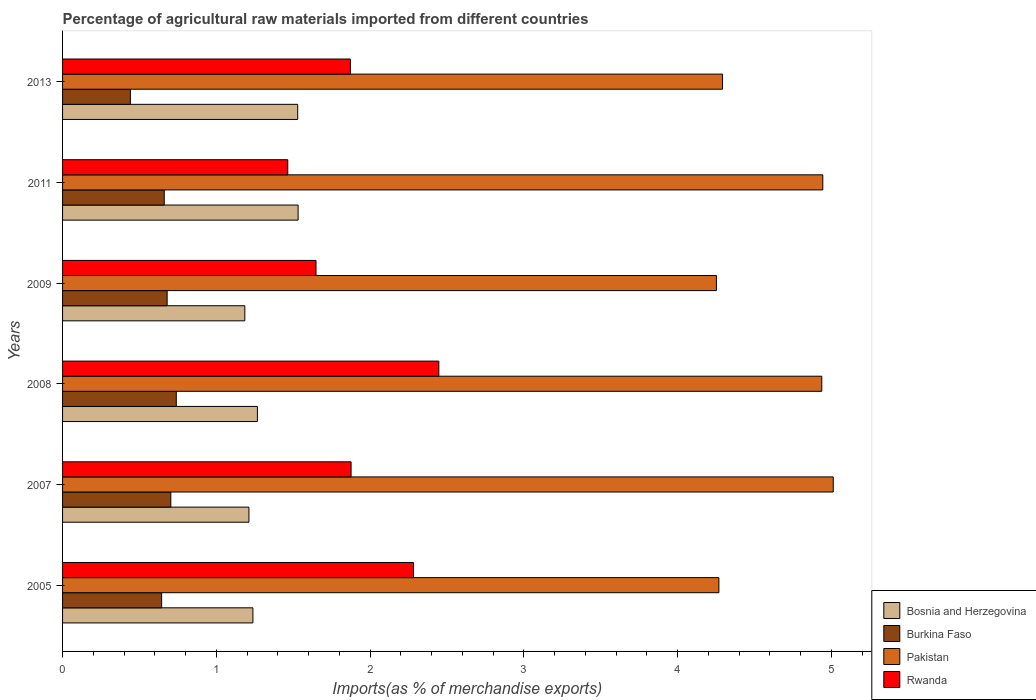How many groups of bars are there?
Give a very brief answer. 6. How many bars are there on the 5th tick from the bottom?
Give a very brief answer. 4. What is the label of the 3rd group of bars from the top?
Offer a terse response. 2009. In how many cases, is the number of bars for a given year not equal to the number of legend labels?
Ensure brevity in your answer.  0. What is the percentage of imports to different countries in Rwanda in 2013?
Provide a short and direct response. 1.87. Across all years, what is the maximum percentage of imports to different countries in Burkina Faso?
Your response must be concise. 0.74. Across all years, what is the minimum percentage of imports to different countries in Bosnia and Herzegovina?
Provide a succinct answer. 1.19. In which year was the percentage of imports to different countries in Bosnia and Herzegovina maximum?
Offer a very short reply. 2011. In which year was the percentage of imports to different countries in Pakistan minimum?
Offer a very short reply. 2009. What is the total percentage of imports to different countries in Rwanda in the graph?
Keep it short and to the point. 11.59. What is the difference between the percentage of imports to different countries in Bosnia and Herzegovina in 2007 and that in 2009?
Provide a short and direct response. 0.03. What is the difference between the percentage of imports to different countries in Burkina Faso in 2009 and the percentage of imports to different countries in Bosnia and Herzegovina in 2011?
Offer a very short reply. -0.85. What is the average percentage of imports to different countries in Pakistan per year?
Ensure brevity in your answer.  4.62. In the year 2009, what is the difference between the percentage of imports to different countries in Rwanda and percentage of imports to different countries in Pakistan?
Ensure brevity in your answer.  -2.6. In how many years, is the percentage of imports to different countries in Burkina Faso greater than 5 %?
Offer a terse response. 0. What is the ratio of the percentage of imports to different countries in Rwanda in 2007 to that in 2009?
Keep it short and to the point. 1.14. Is the percentage of imports to different countries in Bosnia and Herzegovina in 2005 less than that in 2011?
Ensure brevity in your answer.  Yes. What is the difference between the highest and the second highest percentage of imports to different countries in Burkina Faso?
Make the answer very short. 0.04. What is the difference between the highest and the lowest percentage of imports to different countries in Pakistan?
Offer a very short reply. 0.76. Is it the case that in every year, the sum of the percentage of imports to different countries in Bosnia and Herzegovina and percentage of imports to different countries in Rwanda is greater than the sum of percentage of imports to different countries in Pakistan and percentage of imports to different countries in Burkina Faso?
Provide a succinct answer. No. What does the 4th bar from the top in 2005 represents?
Keep it short and to the point. Bosnia and Herzegovina. What does the 3rd bar from the bottom in 2009 represents?
Your response must be concise. Pakistan. How many bars are there?
Provide a short and direct response. 24. Are all the bars in the graph horizontal?
Make the answer very short. Yes. What is the difference between two consecutive major ticks on the X-axis?
Make the answer very short. 1. Are the values on the major ticks of X-axis written in scientific E-notation?
Keep it short and to the point. No. Does the graph contain any zero values?
Provide a succinct answer. No. Does the graph contain grids?
Your response must be concise. No. Where does the legend appear in the graph?
Provide a succinct answer. Bottom right. How many legend labels are there?
Your answer should be very brief. 4. How are the legend labels stacked?
Provide a short and direct response. Vertical. What is the title of the graph?
Your answer should be very brief. Percentage of agricultural raw materials imported from different countries. What is the label or title of the X-axis?
Your answer should be compact. Imports(as % of merchandise exports). What is the label or title of the Y-axis?
Offer a very short reply. Years. What is the Imports(as % of merchandise exports) of Bosnia and Herzegovina in 2005?
Your answer should be compact. 1.24. What is the Imports(as % of merchandise exports) of Burkina Faso in 2005?
Give a very brief answer. 0.64. What is the Imports(as % of merchandise exports) in Pakistan in 2005?
Provide a short and direct response. 4.27. What is the Imports(as % of merchandise exports) in Rwanda in 2005?
Offer a terse response. 2.28. What is the Imports(as % of merchandise exports) in Bosnia and Herzegovina in 2007?
Ensure brevity in your answer.  1.21. What is the Imports(as % of merchandise exports) in Burkina Faso in 2007?
Keep it short and to the point. 0.7. What is the Imports(as % of merchandise exports) in Pakistan in 2007?
Keep it short and to the point. 5.01. What is the Imports(as % of merchandise exports) of Rwanda in 2007?
Keep it short and to the point. 1.88. What is the Imports(as % of merchandise exports) in Bosnia and Herzegovina in 2008?
Your answer should be compact. 1.27. What is the Imports(as % of merchandise exports) of Burkina Faso in 2008?
Your answer should be compact. 0.74. What is the Imports(as % of merchandise exports) in Pakistan in 2008?
Make the answer very short. 4.94. What is the Imports(as % of merchandise exports) in Rwanda in 2008?
Give a very brief answer. 2.45. What is the Imports(as % of merchandise exports) in Bosnia and Herzegovina in 2009?
Your answer should be very brief. 1.19. What is the Imports(as % of merchandise exports) of Burkina Faso in 2009?
Provide a succinct answer. 0.68. What is the Imports(as % of merchandise exports) of Pakistan in 2009?
Your response must be concise. 4.25. What is the Imports(as % of merchandise exports) in Rwanda in 2009?
Your response must be concise. 1.65. What is the Imports(as % of merchandise exports) of Bosnia and Herzegovina in 2011?
Ensure brevity in your answer.  1.53. What is the Imports(as % of merchandise exports) in Burkina Faso in 2011?
Your response must be concise. 0.66. What is the Imports(as % of merchandise exports) in Pakistan in 2011?
Make the answer very short. 4.94. What is the Imports(as % of merchandise exports) of Rwanda in 2011?
Keep it short and to the point. 1.46. What is the Imports(as % of merchandise exports) of Bosnia and Herzegovina in 2013?
Offer a terse response. 1.53. What is the Imports(as % of merchandise exports) in Burkina Faso in 2013?
Make the answer very short. 0.44. What is the Imports(as % of merchandise exports) of Pakistan in 2013?
Give a very brief answer. 4.29. What is the Imports(as % of merchandise exports) in Rwanda in 2013?
Make the answer very short. 1.87. Across all years, what is the maximum Imports(as % of merchandise exports) of Bosnia and Herzegovina?
Make the answer very short. 1.53. Across all years, what is the maximum Imports(as % of merchandise exports) of Burkina Faso?
Provide a succinct answer. 0.74. Across all years, what is the maximum Imports(as % of merchandise exports) in Pakistan?
Your answer should be very brief. 5.01. Across all years, what is the maximum Imports(as % of merchandise exports) of Rwanda?
Provide a succinct answer. 2.45. Across all years, what is the minimum Imports(as % of merchandise exports) of Bosnia and Herzegovina?
Your answer should be very brief. 1.19. Across all years, what is the minimum Imports(as % of merchandise exports) of Burkina Faso?
Give a very brief answer. 0.44. Across all years, what is the minimum Imports(as % of merchandise exports) in Pakistan?
Your answer should be compact. 4.25. Across all years, what is the minimum Imports(as % of merchandise exports) in Rwanda?
Make the answer very short. 1.46. What is the total Imports(as % of merchandise exports) of Bosnia and Herzegovina in the graph?
Make the answer very short. 7.96. What is the total Imports(as % of merchandise exports) in Burkina Faso in the graph?
Ensure brevity in your answer.  3.87. What is the total Imports(as % of merchandise exports) in Pakistan in the graph?
Ensure brevity in your answer.  27.7. What is the total Imports(as % of merchandise exports) in Rwanda in the graph?
Provide a short and direct response. 11.59. What is the difference between the Imports(as % of merchandise exports) in Bosnia and Herzegovina in 2005 and that in 2007?
Give a very brief answer. 0.03. What is the difference between the Imports(as % of merchandise exports) of Burkina Faso in 2005 and that in 2007?
Give a very brief answer. -0.06. What is the difference between the Imports(as % of merchandise exports) in Pakistan in 2005 and that in 2007?
Your answer should be very brief. -0.74. What is the difference between the Imports(as % of merchandise exports) in Rwanda in 2005 and that in 2007?
Offer a very short reply. 0.41. What is the difference between the Imports(as % of merchandise exports) in Bosnia and Herzegovina in 2005 and that in 2008?
Give a very brief answer. -0.03. What is the difference between the Imports(as % of merchandise exports) in Burkina Faso in 2005 and that in 2008?
Give a very brief answer. -0.1. What is the difference between the Imports(as % of merchandise exports) of Pakistan in 2005 and that in 2008?
Your answer should be compact. -0.67. What is the difference between the Imports(as % of merchandise exports) of Rwanda in 2005 and that in 2008?
Provide a succinct answer. -0.16. What is the difference between the Imports(as % of merchandise exports) of Bosnia and Herzegovina in 2005 and that in 2009?
Offer a terse response. 0.05. What is the difference between the Imports(as % of merchandise exports) of Burkina Faso in 2005 and that in 2009?
Give a very brief answer. -0.04. What is the difference between the Imports(as % of merchandise exports) in Pakistan in 2005 and that in 2009?
Your answer should be very brief. 0.02. What is the difference between the Imports(as % of merchandise exports) of Rwanda in 2005 and that in 2009?
Make the answer very short. 0.63. What is the difference between the Imports(as % of merchandise exports) of Bosnia and Herzegovina in 2005 and that in 2011?
Provide a succinct answer. -0.29. What is the difference between the Imports(as % of merchandise exports) in Burkina Faso in 2005 and that in 2011?
Your response must be concise. -0.02. What is the difference between the Imports(as % of merchandise exports) in Pakistan in 2005 and that in 2011?
Provide a succinct answer. -0.68. What is the difference between the Imports(as % of merchandise exports) of Rwanda in 2005 and that in 2011?
Provide a short and direct response. 0.82. What is the difference between the Imports(as % of merchandise exports) in Bosnia and Herzegovina in 2005 and that in 2013?
Make the answer very short. -0.29. What is the difference between the Imports(as % of merchandise exports) in Burkina Faso in 2005 and that in 2013?
Make the answer very short. 0.2. What is the difference between the Imports(as % of merchandise exports) in Pakistan in 2005 and that in 2013?
Offer a terse response. -0.02. What is the difference between the Imports(as % of merchandise exports) in Rwanda in 2005 and that in 2013?
Your answer should be very brief. 0.41. What is the difference between the Imports(as % of merchandise exports) of Bosnia and Herzegovina in 2007 and that in 2008?
Provide a short and direct response. -0.06. What is the difference between the Imports(as % of merchandise exports) of Burkina Faso in 2007 and that in 2008?
Provide a short and direct response. -0.04. What is the difference between the Imports(as % of merchandise exports) of Pakistan in 2007 and that in 2008?
Give a very brief answer. 0.07. What is the difference between the Imports(as % of merchandise exports) of Rwanda in 2007 and that in 2008?
Keep it short and to the point. -0.57. What is the difference between the Imports(as % of merchandise exports) of Bosnia and Herzegovina in 2007 and that in 2009?
Offer a terse response. 0.03. What is the difference between the Imports(as % of merchandise exports) in Burkina Faso in 2007 and that in 2009?
Provide a succinct answer. 0.02. What is the difference between the Imports(as % of merchandise exports) of Pakistan in 2007 and that in 2009?
Offer a terse response. 0.76. What is the difference between the Imports(as % of merchandise exports) of Rwanda in 2007 and that in 2009?
Your answer should be compact. 0.23. What is the difference between the Imports(as % of merchandise exports) in Bosnia and Herzegovina in 2007 and that in 2011?
Your response must be concise. -0.32. What is the difference between the Imports(as % of merchandise exports) in Burkina Faso in 2007 and that in 2011?
Keep it short and to the point. 0.04. What is the difference between the Imports(as % of merchandise exports) of Pakistan in 2007 and that in 2011?
Ensure brevity in your answer.  0.07. What is the difference between the Imports(as % of merchandise exports) in Rwanda in 2007 and that in 2011?
Give a very brief answer. 0.41. What is the difference between the Imports(as % of merchandise exports) of Bosnia and Herzegovina in 2007 and that in 2013?
Provide a short and direct response. -0.32. What is the difference between the Imports(as % of merchandise exports) of Burkina Faso in 2007 and that in 2013?
Keep it short and to the point. 0.26. What is the difference between the Imports(as % of merchandise exports) of Pakistan in 2007 and that in 2013?
Your answer should be compact. 0.72. What is the difference between the Imports(as % of merchandise exports) of Rwanda in 2007 and that in 2013?
Keep it short and to the point. 0. What is the difference between the Imports(as % of merchandise exports) of Bosnia and Herzegovina in 2008 and that in 2009?
Your answer should be compact. 0.08. What is the difference between the Imports(as % of merchandise exports) in Burkina Faso in 2008 and that in 2009?
Give a very brief answer. 0.06. What is the difference between the Imports(as % of merchandise exports) of Pakistan in 2008 and that in 2009?
Provide a short and direct response. 0.69. What is the difference between the Imports(as % of merchandise exports) of Rwanda in 2008 and that in 2009?
Give a very brief answer. 0.8. What is the difference between the Imports(as % of merchandise exports) in Bosnia and Herzegovina in 2008 and that in 2011?
Ensure brevity in your answer.  -0.26. What is the difference between the Imports(as % of merchandise exports) in Burkina Faso in 2008 and that in 2011?
Your response must be concise. 0.08. What is the difference between the Imports(as % of merchandise exports) of Pakistan in 2008 and that in 2011?
Offer a very short reply. -0.01. What is the difference between the Imports(as % of merchandise exports) of Rwanda in 2008 and that in 2011?
Offer a terse response. 0.98. What is the difference between the Imports(as % of merchandise exports) in Bosnia and Herzegovina in 2008 and that in 2013?
Provide a succinct answer. -0.26. What is the difference between the Imports(as % of merchandise exports) in Burkina Faso in 2008 and that in 2013?
Provide a short and direct response. 0.3. What is the difference between the Imports(as % of merchandise exports) in Pakistan in 2008 and that in 2013?
Your response must be concise. 0.65. What is the difference between the Imports(as % of merchandise exports) in Rwanda in 2008 and that in 2013?
Your response must be concise. 0.58. What is the difference between the Imports(as % of merchandise exports) of Bosnia and Herzegovina in 2009 and that in 2011?
Keep it short and to the point. -0.35. What is the difference between the Imports(as % of merchandise exports) of Burkina Faso in 2009 and that in 2011?
Your answer should be very brief. 0.02. What is the difference between the Imports(as % of merchandise exports) of Pakistan in 2009 and that in 2011?
Keep it short and to the point. -0.69. What is the difference between the Imports(as % of merchandise exports) of Rwanda in 2009 and that in 2011?
Your response must be concise. 0.18. What is the difference between the Imports(as % of merchandise exports) in Bosnia and Herzegovina in 2009 and that in 2013?
Offer a terse response. -0.34. What is the difference between the Imports(as % of merchandise exports) in Burkina Faso in 2009 and that in 2013?
Your response must be concise. 0.24. What is the difference between the Imports(as % of merchandise exports) in Pakistan in 2009 and that in 2013?
Give a very brief answer. -0.04. What is the difference between the Imports(as % of merchandise exports) of Rwanda in 2009 and that in 2013?
Provide a succinct answer. -0.22. What is the difference between the Imports(as % of merchandise exports) of Bosnia and Herzegovina in 2011 and that in 2013?
Offer a terse response. 0. What is the difference between the Imports(as % of merchandise exports) of Burkina Faso in 2011 and that in 2013?
Your answer should be compact. 0.22. What is the difference between the Imports(as % of merchandise exports) of Pakistan in 2011 and that in 2013?
Your response must be concise. 0.65. What is the difference between the Imports(as % of merchandise exports) of Rwanda in 2011 and that in 2013?
Offer a terse response. -0.41. What is the difference between the Imports(as % of merchandise exports) of Bosnia and Herzegovina in 2005 and the Imports(as % of merchandise exports) of Burkina Faso in 2007?
Provide a short and direct response. 0.53. What is the difference between the Imports(as % of merchandise exports) in Bosnia and Herzegovina in 2005 and the Imports(as % of merchandise exports) in Pakistan in 2007?
Give a very brief answer. -3.77. What is the difference between the Imports(as % of merchandise exports) of Bosnia and Herzegovina in 2005 and the Imports(as % of merchandise exports) of Rwanda in 2007?
Give a very brief answer. -0.64. What is the difference between the Imports(as % of merchandise exports) in Burkina Faso in 2005 and the Imports(as % of merchandise exports) in Pakistan in 2007?
Keep it short and to the point. -4.37. What is the difference between the Imports(as % of merchandise exports) of Burkina Faso in 2005 and the Imports(as % of merchandise exports) of Rwanda in 2007?
Offer a terse response. -1.23. What is the difference between the Imports(as % of merchandise exports) in Pakistan in 2005 and the Imports(as % of merchandise exports) in Rwanda in 2007?
Offer a very short reply. 2.39. What is the difference between the Imports(as % of merchandise exports) of Bosnia and Herzegovina in 2005 and the Imports(as % of merchandise exports) of Burkina Faso in 2008?
Keep it short and to the point. 0.5. What is the difference between the Imports(as % of merchandise exports) of Bosnia and Herzegovina in 2005 and the Imports(as % of merchandise exports) of Pakistan in 2008?
Keep it short and to the point. -3.7. What is the difference between the Imports(as % of merchandise exports) of Bosnia and Herzegovina in 2005 and the Imports(as % of merchandise exports) of Rwanda in 2008?
Provide a succinct answer. -1.21. What is the difference between the Imports(as % of merchandise exports) of Burkina Faso in 2005 and the Imports(as % of merchandise exports) of Pakistan in 2008?
Give a very brief answer. -4.29. What is the difference between the Imports(as % of merchandise exports) of Burkina Faso in 2005 and the Imports(as % of merchandise exports) of Rwanda in 2008?
Offer a very short reply. -1.8. What is the difference between the Imports(as % of merchandise exports) in Pakistan in 2005 and the Imports(as % of merchandise exports) in Rwanda in 2008?
Offer a terse response. 1.82. What is the difference between the Imports(as % of merchandise exports) in Bosnia and Herzegovina in 2005 and the Imports(as % of merchandise exports) in Burkina Faso in 2009?
Make the answer very short. 0.56. What is the difference between the Imports(as % of merchandise exports) of Bosnia and Herzegovina in 2005 and the Imports(as % of merchandise exports) of Pakistan in 2009?
Your response must be concise. -3.01. What is the difference between the Imports(as % of merchandise exports) of Bosnia and Herzegovina in 2005 and the Imports(as % of merchandise exports) of Rwanda in 2009?
Keep it short and to the point. -0.41. What is the difference between the Imports(as % of merchandise exports) in Burkina Faso in 2005 and the Imports(as % of merchandise exports) in Pakistan in 2009?
Your answer should be compact. -3.61. What is the difference between the Imports(as % of merchandise exports) in Burkina Faso in 2005 and the Imports(as % of merchandise exports) in Rwanda in 2009?
Your answer should be very brief. -1. What is the difference between the Imports(as % of merchandise exports) in Pakistan in 2005 and the Imports(as % of merchandise exports) in Rwanda in 2009?
Your answer should be very brief. 2.62. What is the difference between the Imports(as % of merchandise exports) of Bosnia and Herzegovina in 2005 and the Imports(as % of merchandise exports) of Burkina Faso in 2011?
Your answer should be compact. 0.58. What is the difference between the Imports(as % of merchandise exports) of Bosnia and Herzegovina in 2005 and the Imports(as % of merchandise exports) of Pakistan in 2011?
Keep it short and to the point. -3.71. What is the difference between the Imports(as % of merchandise exports) in Bosnia and Herzegovina in 2005 and the Imports(as % of merchandise exports) in Rwanda in 2011?
Make the answer very short. -0.23. What is the difference between the Imports(as % of merchandise exports) in Burkina Faso in 2005 and the Imports(as % of merchandise exports) in Pakistan in 2011?
Offer a very short reply. -4.3. What is the difference between the Imports(as % of merchandise exports) of Burkina Faso in 2005 and the Imports(as % of merchandise exports) of Rwanda in 2011?
Provide a short and direct response. -0.82. What is the difference between the Imports(as % of merchandise exports) of Pakistan in 2005 and the Imports(as % of merchandise exports) of Rwanda in 2011?
Your response must be concise. 2.8. What is the difference between the Imports(as % of merchandise exports) in Bosnia and Herzegovina in 2005 and the Imports(as % of merchandise exports) in Burkina Faso in 2013?
Give a very brief answer. 0.8. What is the difference between the Imports(as % of merchandise exports) in Bosnia and Herzegovina in 2005 and the Imports(as % of merchandise exports) in Pakistan in 2013?
Offer a very short reply. -3.05. What is the difference between the Imports(as % of merchandise exports) of Bosnia and Herzegovina in 2005 and the Imports(as % of merchandise exports) of Rwanda in 2013?
Your answer should be very brief. -0.63. What is the difference between the Imports(as % of merchandise exports) in Burkina Faso in 2005 and the Imports(as % of merchandise exports) in Pakistan in 2013?
Keep it short and to the point. -3.65. What is the difference between the Imports(as % of merchandise exports) in Burkina Faso in 2005 and the Imports(as % of merchandise exports) in Rwanda in 2013?
Your answer should be very brief. -1.23. What is the difference between the Imports(as % of merchandise exports) in Pakistan in 2005 and the Imports(as % of merchandise exports) in Rwanda in 2013?
Ensure brevity in your answer.  2.4. What is the difference between the Imports(as % of merchandise exports) in Bosnia and Herzegovina in 2007 and the Imports(as % of merchandise exports) in Burkina Faso in 2008?
Provide a succinct answer. 0.47. What is the difference between the Imports(as % of merchandise exports) in Bosnia and Herzegovina in 2007 and the Imports(as % of merchandise exports) in Pakistan in 2008?
Your answer should be very brief. -3.73. What is the difference between the Imports(as % of merchandise exports) of Bosnia and Herzegovina in 2007 and the Imports(as % of merchandise exports) of Rwanda in 2008?
Provide a succinct answer. -1.23. What is the difference between the Imports(as % of merchandise exports) of Burkina Faso in 2007 and the Imports(as % of merchandise exports) of Pakistan in 2008?
Your answer should be very brief. -4.23. What is the difference between the Imports(as % of merchandise exports) of Burkina Faso in 2007 and the Imports(as % of merchandise exports) of Rwanda in 2008?
Offer a terse response. -1.74. What is the difference between the Imports(as % of merchandise exports) of Pakistan in 2007 and the Imports(as % of merchandise exports) of Rwanda in 2008?
Ensure brevity in your answer.  2.56. What is the difference between the Imports(as % of merchandise exports) in Bosnia and Herzegovina in 2007 and the Imports(as % of merchandise exports) in Burkina Faso in 2009?
Provide a short and direct response. 0.53. What is the difference between the Imports(as % of merchandise exports) in Bosnia and Herzegovina in 2007 and the Imports(as % of merchandise exports) in Pakistan in 2009?
Your response must be concise. -3.04. What is the difference between the Imports(as % of merchandise exports) in Bosnia and Herzegovina in 2007 and the Imports(as % of merchandise exports) in Rwanda in 2009?
Make the answer very short. -0.44. What is the difference between the Imports(as % of merchandise exports) in Burkina Faso in 2007 and the Imports(as % of merchandise exports) in Pakistan in 2009?
Make the answer very short. -3.55. What is the difference between the Imports(as % of merchandise exports) of Burkina Faso in 2007 and the Imports(as % of merchandise exports) of Rwanda in 2009?
Keep it short and to the point. -0.94. What is the difference between the Imports(as % of merchandise exports) of Pakistan in 2007 and the Imports(as % of merchandise exports) of Rwanda in 2009?
Offer a terse response. 3.36. What is the difference between the Imports(as % of merchandise exports) of Bosnia and Herzegovina in 2007 and the Imports(as % of merchandise exports) of Burkina Faso in 2011?
Provide a short and direct response. 0.55. What is the difference between the Imports(as % of merchandise exports) of Bosnia and Herzegovina in 2007 and the Imports(as % of merchandise exports) of Pakistan in 2011?
Ensure brevity in your answer.  -3.73. What is the difference between the Imports(as % of merchandise exports) in Bosnia and Herzegovina in 2007 and the Imports(as % of merchandise exports) in Rwanda in 2011?
Give a very brief answer. -0.25. What is the difference between the Imports(as % of merchandise exports) in Burkina Faso in 2007 and the Imports(as % of merchandise exports) in Pakistan in 2011?
Keep it short and to the point. -4.24. What is the difference between the Imports(as % of merchandise exports) in Burkina Faso in 2007 and the Imports(as % of merchandise exports) in Rwanda in 2011?
Give a very brief answer. -0.76. What is the difference between the Imports(as % of merchandise exports) in Pakistan in 2007 and the Imports(as % of merchandise exports) in Rwanda in 2011?
Your response must be concise. 3.55. What is the difference between the Imports(as % of merchandise exports) of Bosnia and Herzegovina in 2007 and the Imports(as % of merchandise exports) of Burkina Faso in 2013?
Keep it short and to the point. 0.77. What is the difference between the Imports(as % of merchandise exports) of Bosnia and Herzegovina in 2007 and the Imports(as % of merchandise exports) of Pakistan in 2013?
Offer a very short reply. -3.08. What is the difference between the Imports(as % of merchandise exports) of Bosnia and Herzegovina in 2007 and the Imports(as % of merchandise exports) of Rwanda in 2013?
Offer a terse response. -0.66. What is the difference between the Imports(as % of merchandise exports) of Burkina Faso in 2007 and the Imports(as % of merchandise exports) of Pakistan in 2013?
Keep it short and to the point. -3.59. What is the difference between the Imports(as % of merchandise exports) in Burkina Faso in 2007 and the Imports(as % of merchandise exports) in Rwanda in 2013?
Offer a very short reply. -1.17. What is the difference between the Imports(as % of merchandise exports) in Pakistan in 2007 and the Imports(as % of merchandise exports) in Rwanda in 2013?
Provide a succinct answer. 3.14. What is the difference between the Imports(as % of merchandise exports) in Bosnia and Herzegovina in 2008 and the Imports(as % of merchandise exports) in Burkina Faso in 2009?
Offer a terse response. 0.59. What is the difference between the Imports(as % of merchandise exports) in Bosnia and Herzegovina in 2008 and the Imports(as % of merchandise exports) in Pakistan in 2009?
Keep it short and to the point. -2.98. What is the difference between the Imports(as % of merchandise exports) in Bosnia and Herzegovina in 2008 and the Imports(as % of merchandise exports) in Rwanda in 2009?
Your answer should be compact. -0.38. What is the difference between the Imports(as % of merchandise exports) of Burkina Faso in 2008 and the Imports(as % of merchandise exports) of Pakistan in 2009?
Your answer should be very brief. -3.51. What is the difference between the Imports(as % of merchandise exports) in Burkina Faso in 2008 and the Imports(as % of merchandise exports) in Rwanda in 2009?
Your answer should be compact. -0.91. What is the difference between the Imports(as % of merchandise exports) in Pakistan in 2008 and the Imports(as % of merchandise exports) in Rwanda in 2009?
Keep it short and to the point. 3.29. What is the difference between the Imports(as % of merchandise exports) of Bosnia and Herzegovina in 2008 and the Imports(as % of merchandise exports) of Burkina Faso in 2011?
Your answer should be very brief. 0.61. What is the difference between the Imports(as % of merchandise exports) of Bosnia and Herzegovina in 2008 and the Imports(as % of merchandise exports) of Pakistan in 2011?
Your answer should be very brief. -3.68. What is the difference between the Imports(as % of merchandise exports) in Bosnia and Herzegovina in 2008 and the Imports(as % of merchandise exports) in Rwanda in 2011?
Your answer should be very brief. -0.2. What is the difference between the Imports(as % of merchandise exports) in Burkina Faso in 2008 and the Imports(as % of merchandise exports) in Pakistan in 2011?
Offer a very short reply. -4.2. What is the difference between the Imports(as % of merchandise exports) of Burkina Faso in 2008 and the Imports(as % of merchandise exports) of Rwanda in 2011?
Your answer should be compact. -0.72. What is the difference between the Imports(as % of merchandise exports) in Pakistan in 2008 and the Imports(as % of merchandise exports) in Rwanda in 2011?
Your response must be concise. 3.47. What is the difference between the Imports(as % of merchandise exports) in Bosnia and Herzegovina in 2008 and the Imports(as % of merchandise exports) in Burkina Faso in 2013?
Keep it short and to the point. 0.83. What is the difference between the Imports(as % of merchandise exports) in Bosnia and Herzegovina in 2008 and the Imports(as % of merchandise exports) in Pakistan in 2013?
Offer a very short reply. -3.02. What is the difference between the Imports(as % of merchandise exports) of Bosnia and Herzegovina in 2008 and the Imports(as % of merchandise exports) of Rwanda in 2013?
Keep it short and to the point. -0.6. What is the difference between the Imports(as % of merchandise exports) in Burkina Faso in 2008 and the Imports(as % of merchandise exports) in Pakistan in 2013?
Give a very brief answer. -3.55. What is the difference between the Imports(as % of merchandise exports) of Burkina Faso in 2008 and the Imports(as % of merchandise exports) of Rwanda in 2013?
Provide a succinct answer. -1.13. What is the difference between the Imports(as % of merchandise exports) in Pakistan in 2008 and the Imports(as % of merchandise exports) in Rwanda in 2013?
Your answer should be compact. 3.07. What is the difference between the Imports(as % of merchandise exports) in Bosnia and Herzegovina in 2009 and the Imports(as % of merchandise exports) in Burkina Faso in 2011?
Give a very brief answer. 0.52. What is the difference between the Imports(as % of merchandise exports) of Bosnia and Herzegovina in 2009 and the Imports(as % of merchandise exports) of Pakistan in 2011?
Offer a terse response. -3.76. What is the difference between the Imports(as % of merchandise exports) in Bosnia and Herzegovina in 2009 and the Imports(as % of merchandise exports) in Rwanda in 2011?
Offer a very short reply. -0.28. What is the difference between the Imports(as % of merchandise exports) in Burkina Faso in 2009 and the Imports(as % of merchandise exports) in Pakistan in 2011?
Your answer should be very brief. -4.26. What is the difference between the Imports(as % of merchandise exports) of Burkina Faso in 2009 and the Imports(as % of merchandise exports) of Rwanda in 2011?
Make the answer very short. -0.78. What is the difference between the Imports(as % of merchandise exports) in Pakistan in 2009 and the Imports(as % of merchandise exports) in Rwanda in 2011?
Keep it short and to the point. 2.79. What is the difference between the Imports(as % of merchandise exports) in Bosnia and Herzegovina in 2009 and the Imports(as % of merchandise exports) in Burkina Faso in 2013?
Provide a succinct answer. 0.74. What is the difference between the Imports(as % of merchandise exports) of Bosnia and Herzegovina in 2009 and the Imports(as % of merchandise exports) of Pakistan in 2013?
Your response must be concise. -3.11. What is the difference between the Imports(as % of merchandise exports) in Bosnia and Herzegovina in 2009 and the Imports(as % of merchandise exports) in Rwanda in 2013?
Provide a short and direct response. -0.69. What is the difference between the Imports(as % of merchandise exports) of Burkina Faso in 2009 and the Imports(as % of merchandise exports) of Pakistan in 2013?
Your answer should be compact. -3.61. What is the difference between the Imports(as % of merchandise exports) in Burkina Faso in 2009 and the Imports(as % of merchandise exports) in Rwanda in 2013?
Give a very brief answer. -1.19. What is the difference between the Imports(as % of merchandise exports) of Pakistan in 2009 and the Imports(as % of merchandise exports) of Rwanda in 2013?
Make the answer very short. 2.38. What is the difference between the Imports(as % of merchandise exports) in Bosnia and Herzegovina in 2011 and the Imports(as % of merchandise exports) in Burkina Faso in 2013?
Your answer should be compact. 1.09. What is the difference between the Imports(as % of merchandise exports) of Bosnia and Herzegovina in 2011 and the Imports(as % of merchandise exports) of Pakistan in 2013?
Give a very brief answer. -2.76. What is the difference between the Imports(as % of merchandise exports) in Bosnia and Herzegovina in 2011 and the Imports(as % of merchandise exports) in Rwanda in 2013?
Offer a very short reply. -0.34. What is the difference between the Imports(as % of merchandise exports) of Burkina Faso in 2011 and the Imports(as % of merchandise exports) of Pakistan in 2013?
Provide a succinct answer. -3.63. What is the difference between the Imports(as % of merchandise exports) in Burkina Faso in 2011 and the Imports(as % of merchandise exports) in Rwanda in 2013?
Your answer should be compact. -1.21. What is the difference between the Imports(as % of merchandise exports) of Pakistan in 2011 and the Imports(as % of merchandise exports) of Rwanda in 2013?
Provide a short and direct response. 3.07. What is the average Imports(as % of merchandise exports) in Bosnia and Herzegovina per year?
Provide a succinct answer. 1.33. What is the average Imports(as % of merchandise exports) of Burkina Faso per year?
Ensure brevity in your answer.  0.65. What is the average Imports(as % of merchandise exports) in Pakistan per year?
Keep it short and to the point. 4.62. What is the average Imports(as % of merchandise exports) in Rwanda per year?
Offer a very short reply. 1.93. In the year 2005, what is the difference between the Imports(as % of merchandise exports) in Bosnia and Herzegovina and Imports(as % of merchandise exports) in Burkina Faso?
Your response must be concise. 0.59. In the year 2005, what is the difference between the Imports(as % of merchandise exports) in Bosnia and Herzegovina and Imports(as % of merchandise exports) in Pakistan?
Your answer should be compact. -3.03. In the year 2005, what is the difference between the Imports(as % of merchandise exports) in Bosnia and Herzegovina and Imports(as % of merchandise exports) in Rwanda?
Your answer should be very brief. -1.04. In the year 2005, what is the difference between the Imports(as % of merchandise exports) in Burkina Faso and Imports(as % of merchandise exports) in Pakistan?
Keep it short and to the point. -3.62. In the year 2005, what is the difference between the Imports(as % of merchandise exports) of Burkina Faso and Imports(as % of merchandise exports) of Rwanda?
Give a very brief answer. -1.64. In the year 2005, what is the difference between the Imports(as % of merchandise exports) of Pakistan and Imports(as % of merchandise exports) of Rwanda?
Ensure brevity in your answer.  1.99. In the year 2007, what is the difference between the Imports(as % of merchandise exports) of Bosnia and Herzegovina and Imports(as % of merchandise exports) of Burkina Faso?
Provide a succinct answer. 0.51. In the year 2007, what is the difference between the Imports(as % of merchandise exports) in Bosnia and Herzegovina and Imports(as % of merchandise exports) in Pakistan?
Your answer should be very brief. -3.8. In the year 2007, what is the difference between the Imports(as % of merchandise exports) of Bosnia and Herzegovina and Imports(as % of merchandise exports) of Rwanda?
Your response must be concise. -0.66. In the year 2007, what is the difference between the Imports(as % of merchandise exports) in Burkina Faso and Imports(as % of merchandise exports) in Pakistan?
Your answer should be compact. -4.31. In the year 2007, what is the difference between the Imports(as % of merchandise exports) in Burkina Faso and Imports(as % of merchandise exports) in Rwanda?
Your answer should be very brief. -1.17. In the year 2007, what is the difference between the Imports(as % of merchandise exports) in Pakistan and Imports(as % of merchandise exports) in Rwanda?
Provide a succinct answer. 3.14. In the year 2008, what is the difference between the Imports(as % of merchandise exports) of Bosnia and Herzegovina and Imports(as % of merchandise exports) of Burkina Faso?
Offer a terse response. 0.53. In the year 2008, what is the difference between the Imports(as % of merchandise exports) in Bosnia and Herzegovina and Imports(as % of merchandise exports) in Pakistan?
Provide a succinct answer. -3.67. In the year 2008, what is the difference between the Imports(as % of merchandise exports) of Bosnia and Herzegovina and Imports(as % of merchandise exports) of Rwanda?
Offer a very short reply. -1.18. In the year 2008, what is the difference between the Imports(as % of merchandise exports) in Burkina Faso and Imports(as % of merchandise exports) in Pakistan?
Your answer should be compact. -4.2. In the year 2008, what is the difference between the Imports(as % of merchandise exports) of Burkina Faso and Imports(as % of merchandise exports) of Rwanda?
Make the answer very short. -1.71. In the year 2008, what is the difference between the Imports(as % of merchandise exports) in Pakistan and Imports(as % of merchandise exports) in Rwanda?
Provide a succinct answer. 2.49. In the year 2009, what is the difference between the Imports(as % of merchandise exports) in Bosnia and Herzegovina and Imports(as % of merchandise exports) in Burkina Faso?
Ensure brevity in your answer.  0.51. In the year 2009, what is the difference between the Imports(as % of merchandise exports) of Bosnia and Herzegovina and Imports(as % of merchandise exports) of Pakistan?
Give a very brief answer. -3.07. In the year 2009, what is the difference between the Imports(as % of merchandise exports) of Bosnia and Herzegovina and Imports(as % of merchandise exports) of Rwanda?
Your answer should be compact. -0.46. In the year 2009, what is the difference between the Imports(as % of merchandise exports) of Burkina Faso and Imports(as % of merchandise exports) of Pakistan?
Offer a very short reply. -3.57. In the year 2009, what is the difference between the Imports(as % of merchandise exports) of Burkina Faso and Imports(as % of merchandise exports) of Rwanda?
Your response must be concise. -0.97. In the year 2009, what is the difference between the Imports(as % of merchandise exports) in Pakistan and Imports(as % of merchandise exports) in Rwanda?
Make the answer very short. 2.6. In the year 2011, what is the difference between the Imports(as % of merchandise exports) of Bosnia and Herzegovina and Imports(as % of merchandise exports) of Burkina Faso?
Offer a very short reply. 0.87. In the year 2011, what is the difference between the Imports(as % of merchandise exports) in Bosnia and Herzegovina and Imports(as % of merchandise exports) in Pakistan?
Your answer should be compact. -3.41. In the year 2011, what is the difference between the Imports(as % of merchandise exports) of Bosnia and Herzegovina and Imports(as % of merchandise exports) of Rwanda?
Offer a terse response. 0.07. In the year 2011, what is the difference between the Imports(as % of merchandise exports) of Burkina Faso and Imports(as % of merchandise exports) of Pakistan?
Make the answer very short. -4.28. In the year 2011, what is the difference between the Imports(as % of merchandise exports) of Burkina Faso and Imports(as % of merchandise exports) of Rwanda?
Make the answer very short. -0.8. In the year 2011, what is the difference between the Imports(as % of merchandise exports) in Pakistan and Imports(as % of merchandise exports) in Rwanda?
Provide a succinct answer. 3.48. In the year 2013, what is the difference between the Imports(as % of merchandise exports) in Bosnia and Herzegovina and Imports(as % of merchandise exports) in Burkina Faso?
Provide a succinct answer. 1.09. In the year 2013, what is the difference between the Imports(as % of merchandise exports) in Bosnia and Herzegovina and Imports(as % of merchandise exports) in Pakistan?
Provide a short and direct response. -2.76. In the year 2013, what is the difference between the Imports(as % of merchandise exports) of Bosnia and Herzegovina and Imports(as % of merchandise exports) of Rwanda?
Your answer should be very brief. -0.34. In the year 2013, what is the difference between the Imports(as % of merchandise exports) in Burkina Faso and Imports(as % of merchandise exports) in Pakistan?
Keep it short and to the point. -3.85. In the year 2013, what is the difference between the Imports(as % of merchandise exports) in Burkina Faso and Imports(as % of merchandise exports) in Rwanda?
Your response must be concise. -1.43. In the year 2013, what is the difference between the Imports(as % of merchandise exports) of Pakistan and Imports(as % of merchandise exports) of Rwanda?
Offer a terse response. 2.42. What is the ratio of the Imports(as % of merchandise exports) of Bosnia and Herzegovina in 2005 to that in 2007?
Your response must be concise. 1.02. What is the ratio of the Imports(as % of merchandise exports) of Burkina Faso in 2005 to that in 2007?
Provide a succinct answer. 0.92. What is the ratio of the Imports(as % of merchandise exports) in Pakistan in 2005 to that in 2007?
Give a very brief answer. 0.85. What is the ratio of the Imports(as % of merchandise exports) in Rwanda in 2005 to that in 2007?
Provide a succinct answer. 1.22. What is the ratio of the Imports(as % of merchandise exports) in Bosnia and Herzegovina in 2005 to that in 2008?
Your answer should be compact. 0.98. What is the ratio of the Imports(as % of merchandise exports) in Burkina Faso in 2005 to that in 2008?
Ensure brevity in your answer.  0.87. What is the ratio of the Imports(as % of merchandise exports) of Pakistan in 2005 to that in 2008?
Your answer should be very brief. 0.86. What is the ratio of the Imports(as % of merchandise exports) in Rwanda in 2005 to that in 2008?
Give a very brief answer. 0.93. What is the ratio of the Imports(as % of merchandise exports) of Bosnia and Herzegovina in 2005 to that in 2009?
Your response must be concise. 1.04. What is the ratio of the Imports(as % of merchandise exports) of Burkina Faso in 2005 to that in 2009?
Your answer should be compact. 0.95. What is the ratio of the Imports(as % of merchandise exports) of Rwanda in 2005 to that in 2009?
Give a very brief answer. 1.38. What is the ratio of the Imports(as % of merchandise exports) in Bosnia and Herzegovina in 2005 to that in 2011?
Your answer should be compact. 0.81. What is the ratio of the Imports(as % of merchandise exports) in Burkina Faso in 2005 to that in 2011?
Give a very brief answer. 0.97. What is the ratio of the Imports(as % of merchandise exports) in Pakistan in 2005 to that in 2011?
Offer a terse response. 0.86. What is the ratio of the Imports(as % of merchandise exports) in Rwanda in 2005 to that in 2011?
Make the answer very short. 1.56. What is the ratio of the Imports(as % of merchandise exports) in Bosnia and Herzegovina in 2005 to that in 2013?
Offer a very short reply. 0.81. What is the ratio of the Imports(as % of merchandise exports) in Burkina Faso in 2005 to that in 2013?
Your answer should be compact. 1.46. What is the ratio of the Imports(as % of merchandise exports) in Pakistan in 2005 to that in 2013?
Your answer should be compact. 0.99. What is the ratio of the Imports(as % of merchandise exports) in Rwanda in 2005 to that in 2013?
Your answer should be compact. 1.22. What is the ratio of the Imports(as % of merchandise exports) in Bosnia and Herzegovina in 2007 to that in 2008?
Your answer should be very brief. 0.96. What is the ratio of the Imports(as % of merchandise exports) of Burkina Faso in 2007 to that in 2008?
Offer a very short reply. 0.95. What is the ratio of the Imports(as % of merchandise exports) in Pakistan in 2007 to that in 2008?
Provide a short and direct response. 1.02. What is the ratio of the Imports(as % of merchandise exports) in Rwanda in 2007 to that in 2008?
Your answer should be very brief. 0.77. What is the ratio of the Imports(as % of merchandise exports) in Bosnia and Herzegovina in 2007 to that in 2009?
Offer a terse response. 1.02. What is the ratio of the Imports(as % of merchandise exports) of Burkina Faso in 2007 to that in 2009?
Offer a very short reply. 1.04. What is the ratio of the Imports(as % of merchandise exports) of Pakistan in 2007 to that in 2009?
Offer a terse response. 1.18. What is the ratio of the Imports(as % of merchandise exports) of Rwanda in 2007 to that in 2009?
Offer a terse response. 1.14. What is the ratio of the Imports(as % of merchandise exports) of Bosnia and Herzegovina in 2007 to that in 2011?
Offer a terse response. 0.79. What is the ratio of the Imports(as % of merchandise exports) of Burkina Faso in 2007 to that in 2011?
Your answer should be compact. 1.06. What is the ratio of the Imports(as % of merchandise exports) of Pakistan in 2007 to that in 2011?
Your response must be concise. 1.01. What is the ratio of the Imports(as % of merchandise exports) of Rwanda in 2007 to that in 2011?
Your response must be concise. 1.28. What is the ratio of the Imports(as % of merchandise exports) of Bosnia and Herzegovina in 2007 to that in 2013?
Your answer should be compact. 0.79. What is the ratio of the Imports(as % of merchandise exports) of Burkina Faso in 2007 to that in 2013?
Offer a very short reply. 1.6. What is the ratio of the Imports(as % of merchandise exports) of Pakistan in 2007 to that in 2013?
Your answer should be very brief. 1.17. What is the ratio of the Imports(as % of merchandise exports) of Rwanda in 2007 to that in 2013?
Keep it short and to the point. 1. What is the ratio of the Imports(as % of merchandise exports) of Bosnia and Herzegovina in 2008 to that in 2009?
Your answer should be very brief. 1.07. What is the ratio of the Imports(as % of merchandise exports) of Burkina Faso in 2008 to that in 2009?
Your response must be concise. 1.09. What is the ratio of the Imports(as % of merchandise exports) of Pakistan in 2008 to that in 2009?
Offer a very short reply. 1.16. What is the ratio of the Imports(as % of merchandise exports) of Rwanda in 2008 to that in 2009?
Provide a succinct answer. 1.48. What is the ratio of the Imports(as % of merchandise exports) of Bosnia and Herzegovina in 2008 to that in 2011?
Provide a succinct answer. 0.83. What is the ratio of the Imports(as % of merchandise exports) in Burkina Faso in 2008 to that in 2011?
Your answer should be compact. 1.12. What is the ratio of the Imports(as % of merchandise exports) in Rwanda in 2008 to that in 2011?
Ensure brevity in your answer.  1.67. What is the ratio of the Imports(as % of merchandise exports) in Bosnia and Herzegovina in 2008 to that in 2013?
Offer a terse response. 0.83. What is the ratio of the Imports(as % of merchandise exports) in Burkina Faso in 2008 to that in 2013?
Provide a short and direct response. 1.68. What is the ratio of the Imports(as % of merchandise exports) of Pakistan in 2008 to that in 2013?
Provide a short and direct response. 1.15. What is the ratio of the Imports(as % of merchandise exports) of Rwanda in 2008 to that in 2013?
Give a very brief answer. 1.31. What is the ratio of the Imports(as % of merchandise exports) in Bosnia and Herzegovina in 2009 to that in 2011?
Offer a terse response. 0.77. What is the ratio of the Imports(as % of merchandise exports) of Burkina Faso in 2009 to that in 2011?
Your answer should be very brief. 1.03. What is the ratio of the Imports(as % of merchandise exports) in Pakistan in 2009 to that in 2011?
Make the answer very short. 0.86. What is the ratio of the Imports(as % of merchandise exports) of Rwanda in 2009 to that in 2011?
Provide a short and direct response. 1.13. What is the ratio of the Imports(as % of merchandise exports) of Bosnia and Herzegovina in 2009 to that in 2013?
Ensure brevity in your answer.  0.78. What is the ratio of the Imports(as % of merchandise exports) of Burkina Faso in 2009 to that in 2013?
Offer a very short reply. 1.54. What is the ratio of the Imports(as % of merchandise exports) in Pakistan in 2009 to that in 2013?
Make the answer very short. 0.99. What is the ratio of the Imports(as % of merchandise exports) of Rwanda in 2009 to that in 2013?
Give a very brief answer. 0.88. What is the ratio of the Imports(as % of merchandise exports) in Burkina Faso in 2011 to that in 2013?
Offer a very short reply. 1.5. What is the ratio of the Imports(as % of merchandise exports) in Pakistan in 2011 to that in 2013?
Provide a short and direct response. 1.15. What is the ratio of the Imports(as % of merchandise exports) of Rwanda in 2011 to that in 2013?
Provide a short and direct response. 0.78. What is the difference between the highest and the second highest Imports(as % of merchandise exports) of Bosnia and Herzegovina?
Offer a very short reply. 0. What is the difference between the highest and the second highest Imports(as % of merchandise exports) in Burkina Faso?
Your response must be concise. 0.04. What is the difference between the highest and the second highest Imports(as % of merchandise exports) in Pakistan?
Your answer should be compact. 0.07. What is the difference between the highest and the second highest Imports(as % of merchandise exports) of Rwanda?
Offer a terse response. 0.16. What is the difference between the highest and the lowest Imports(as % of merchandise exports) of Bosnia and Herzegovina?
Keep it short and to the point. 0.35. What is the difference between the highest and the lowest Imports(as % of merchandise exports) of Burkina Faso?
Make the answer very short. 0.3. What is the difference between the highest and the lowest Imports(as % of merchandise exports) in Pakistan?
Your response must be concise. 0.76. What is the difference between the highest and the lowest Imports(as % of merchandise exports) in Rwanda?
Your response must be concise. 0.98. 